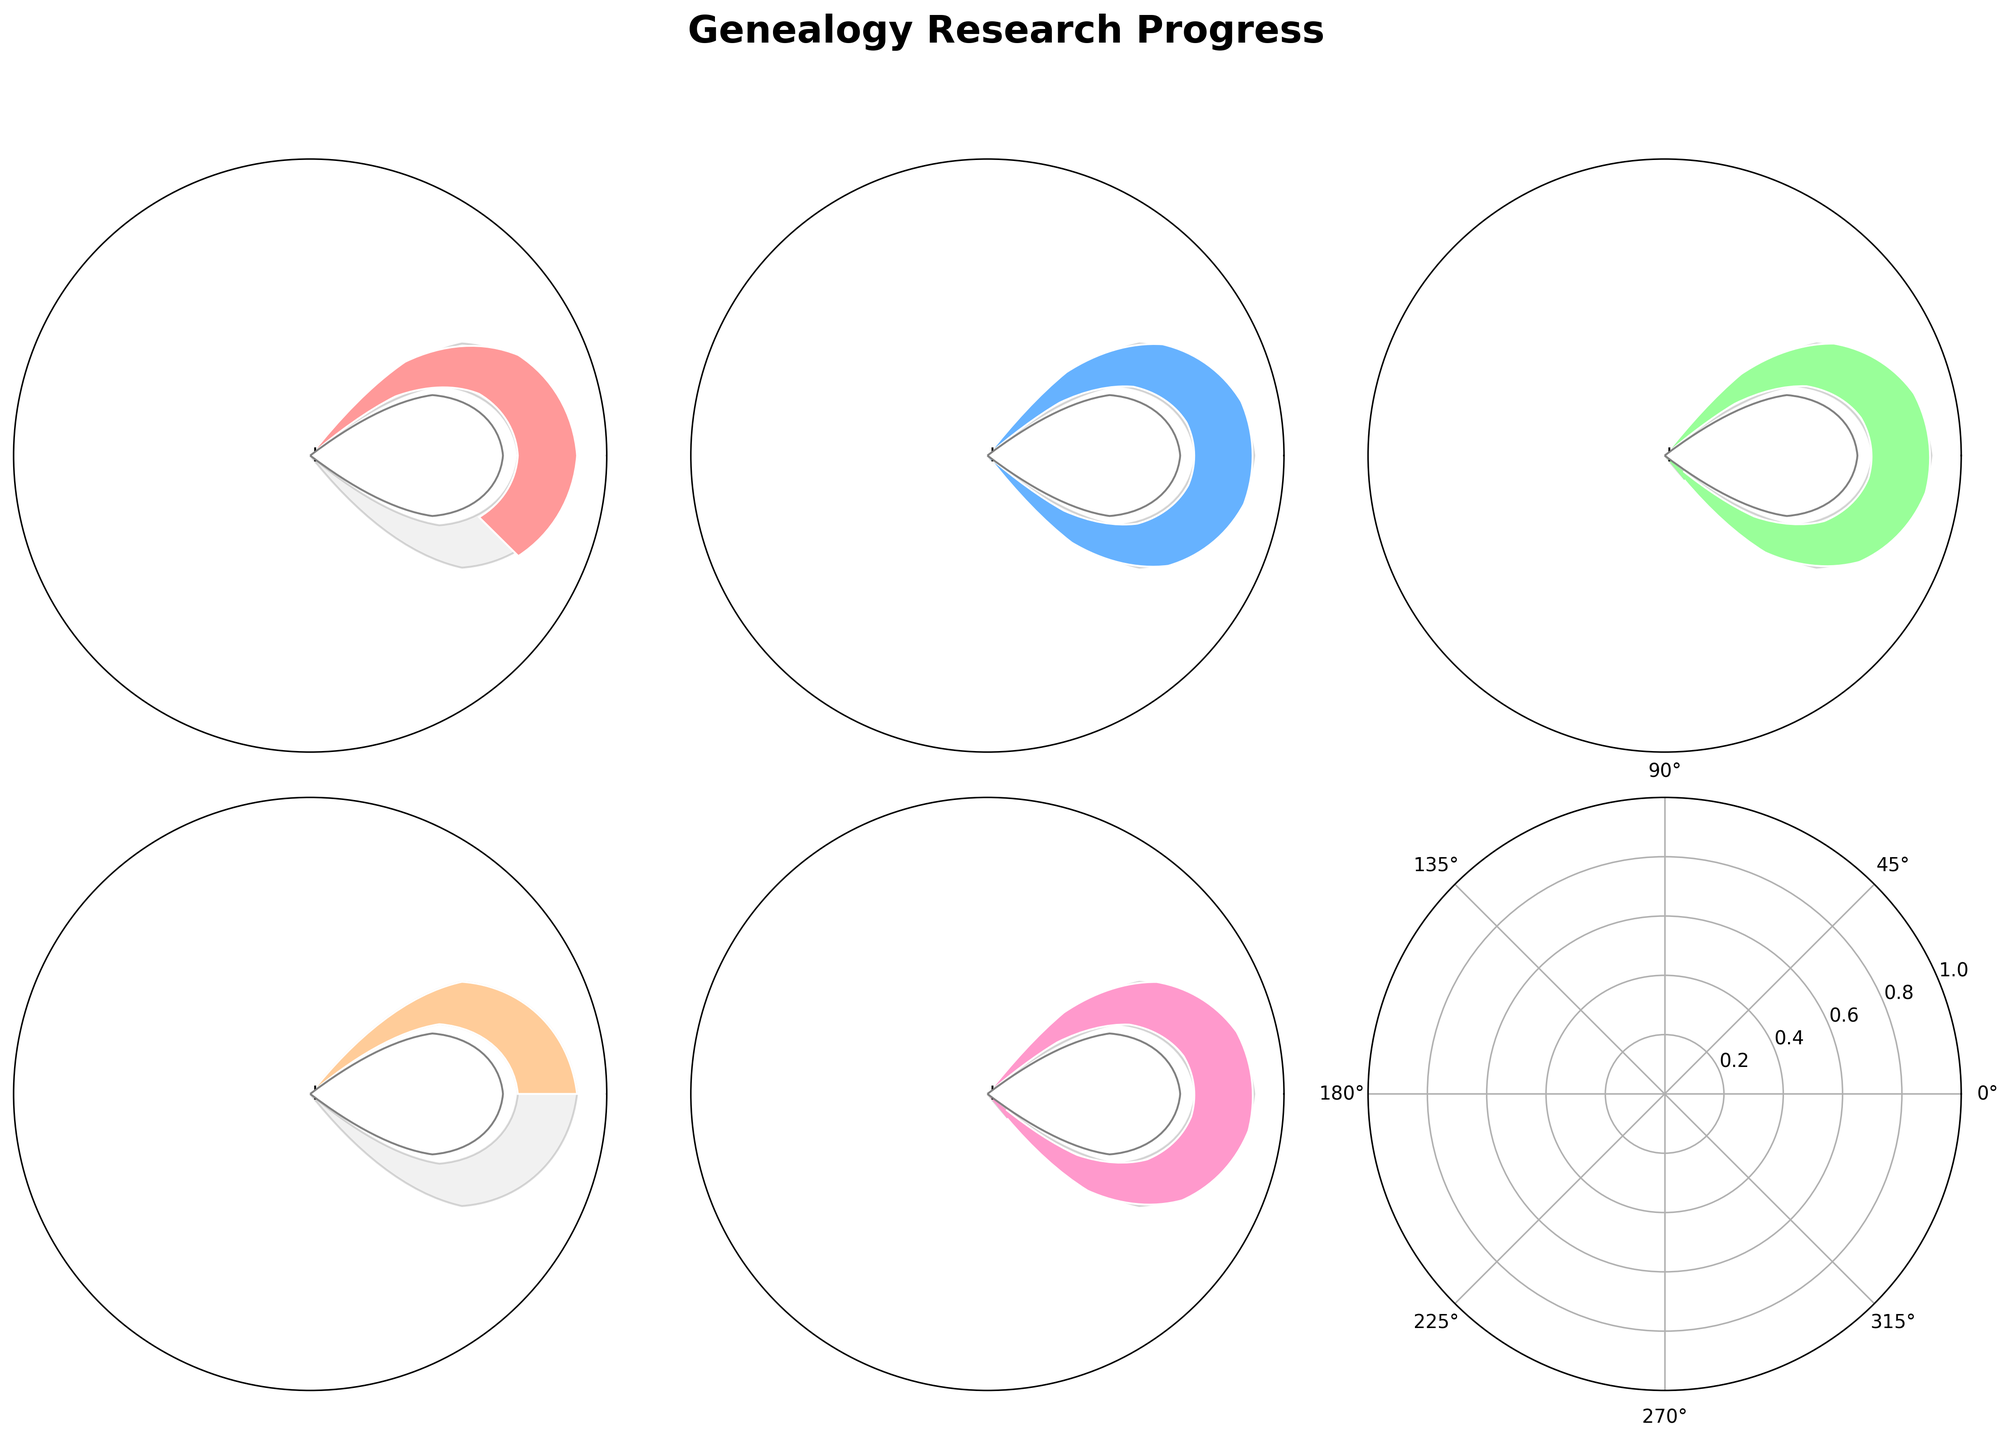What is the total time you spent on genealogy research in Week 1? In Week 1, the actual hours reported is 8.
Answer: 8 hours How many weeks have you exceeded your genealogy research goals? Week 2 and Week 3 have actual hours (17 and 22) greater than their respective goals (15 and 20).
Answer: 2 weeks What’s the average goal set for all weeks? The goals set for each of the weeks are 12, 15, 20, 8, and 10 giving a total of 65 hours over 5 weeks, so the average is 65/5.
Answer: 13 hours In which week did you underperform the most compared to the goal? In Week 4, the goal was 8 hours, and the actual time spent was 4 hours, which is the largest negative difference of 4 hours.
Answer: Week 4 What are the actual hours spent in Week 5? In Week 5, the actual hours reported is 11.
Answer: 11 hours During which week did you achieve exactly your goal? In Week 2, the actual hours and the goal both are 15 hours.
Answer: Week 2 How many weeks have you underperformed compared to the goal? Week 1, Week 4, and Week 5 have actual hours (8, 4, 11) less than their goals (12, 8, 10).
Answer: 3 weeks What is the color used for representing Week 2 on the gauge chart? The color for Week 2 on the gauge chart is light blue.
Answer: light blue What's the total actual hours spent on genealogy research over the 5 weeks? The actual hours spent in each of the weeks are 8, 17, 22, 4, and 11, giving a total of 62 hours.
Answer: 62 hours Which week had the highest number of actual hours spent on genealogy research? Week 3 with 22 actual hours spent has the highest number.
Answer: Week 3 